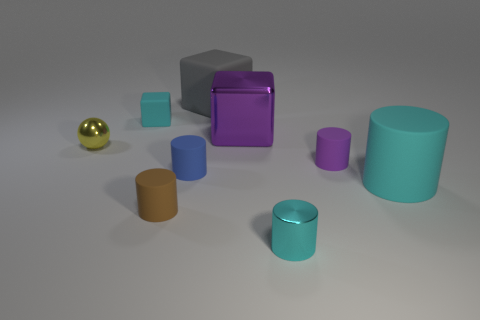Subtract all tiny blue cylinders. How many cylinders are left? 4 Add 1 balls. How many objects exist? 10 Subtract all cyan cylinders. How many cylinders are left? 3 Subtract all purple balls. How many cyan cylinders are left? 2 Subtract all spheres. How many objects are left? 8 Subtract 3 blocks. How many blocks are left? 0 Add 8 small purple rubber things. How many small purple rubber things exist? 9 Subtract 0 red spheres. How many objects are left? 9 Subtract all red blocks. Subtract all gray balls. How many blocks are left? 3 Subtract all large purple metallic things. Subtract all big purple metallic objects. How many objects are left? 7 